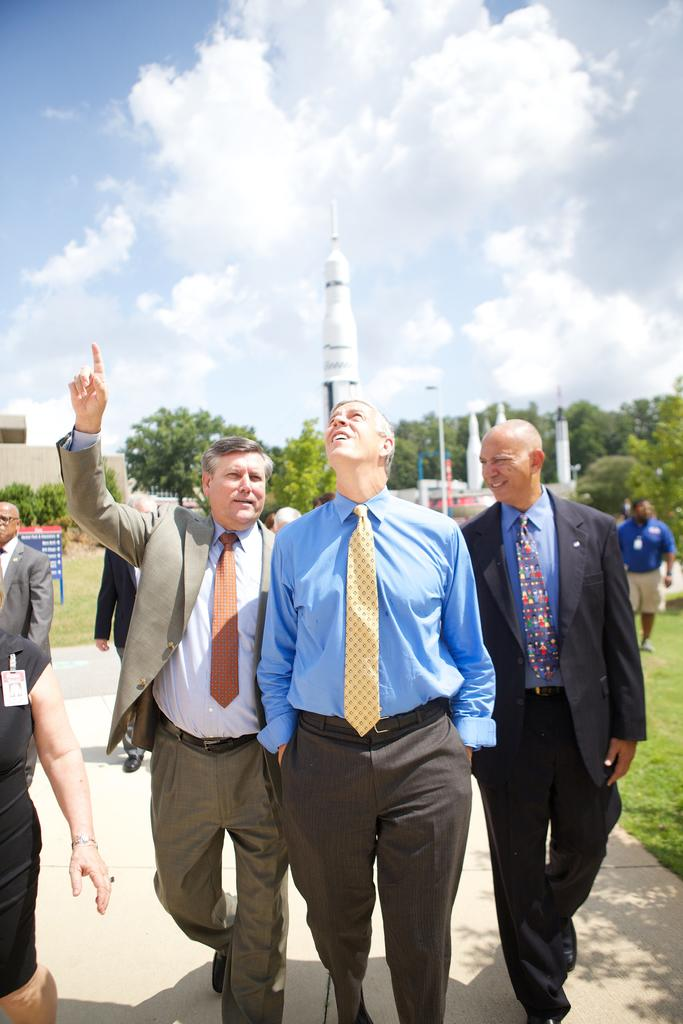How many people are in the image? There are three old men in the image. What are the old men doing in the image? The old men are walking and looking at the sky. What can be seen in the background of the image? There is a white color rocket in the image, and trees are around the rocket. What type of silver insect can be seen flying near the rocket in the image? There is no insect, silver or otherwise, present in the image. 